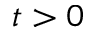Convert formula to latex. <formula><loc_0><loc_0><loc_500><loc_500>t > 0</formula> 